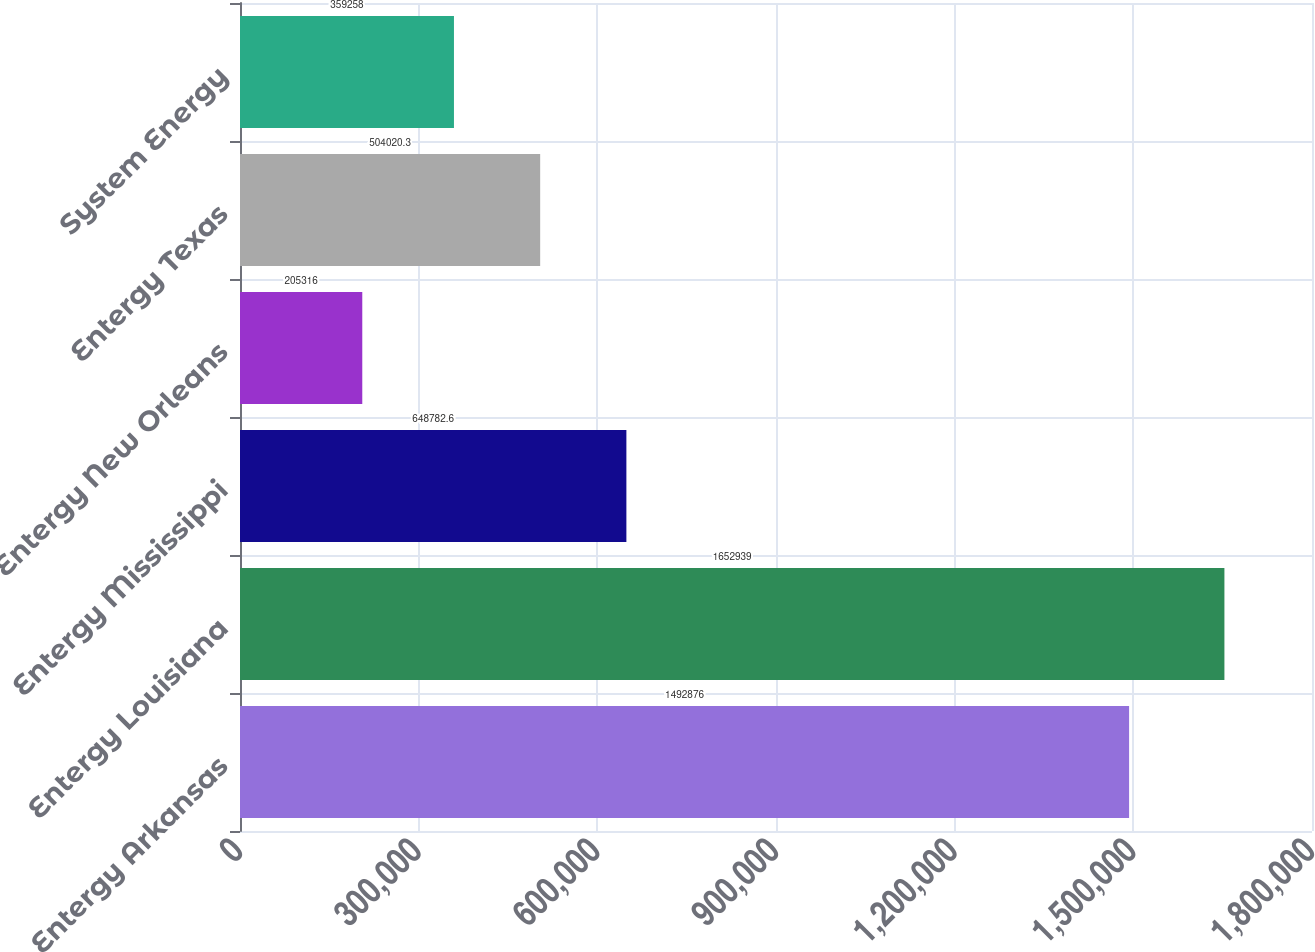Convert chart. <chart><loc_0><loc_0><loc_500><loc_500><bar_chart><fcel>Entergy Arkansas<fcel>Entergy Louisiana<fcel>Entergy Mississippi<fcel>Entergy New Orleans<fcel>Entergy Texas<fcel>System Energy<nl><fcel>1.49288e+06<fcel>1.65294e+06<fcel>648783<fcel>205316<fcel>504020<fcel>359258<nl></chart> 